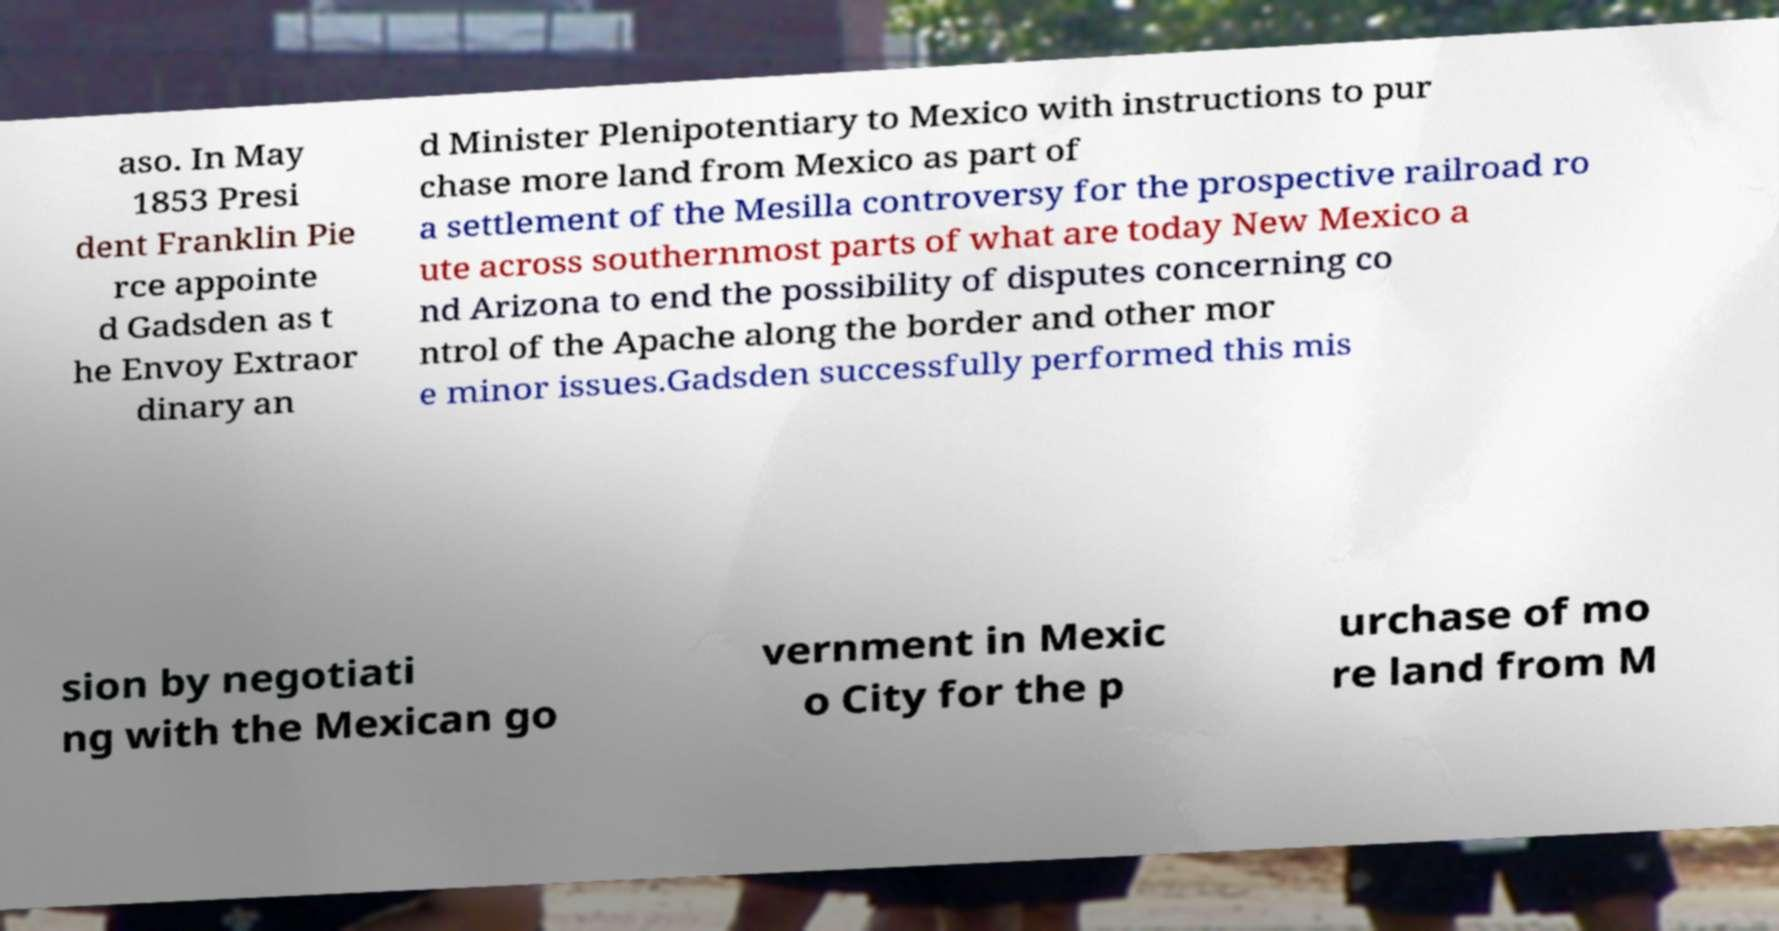I need the written content from this picture converted into text. Can you do that? aso. In May 1853 Presi dent Franklin Pie rce appointe d Gadsden as t he Envoy Extraor dinary an d Minister Plenipotentiary to Mexico with instructions to pur chase more land from Mexico as part of a settlement of the Mesilla controversy for the prospective railroad ro ute across southernmost parts of what are today New Mexico a nd Arizona to end the possibility of disputes concerning co ntrol of the Apache along the border and other mor e minor issues.Gadsden successfully performed this mis sion by negotiati ng with the Mexican go vernment in Mexic o City for the p urchase of mo re land from M 